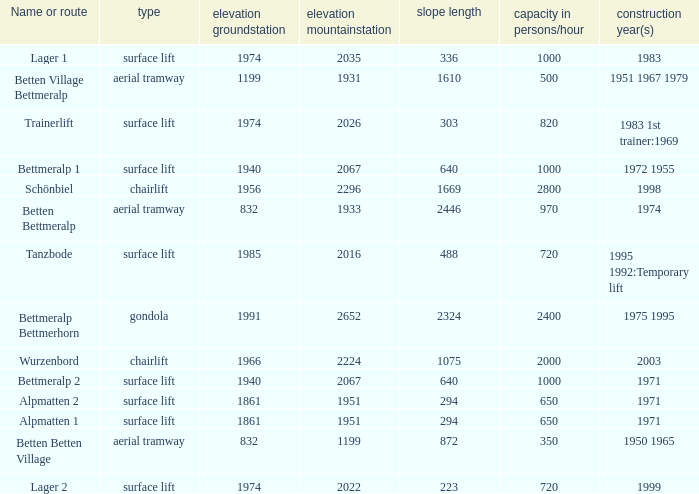Which slope length has a type of surface lift, and an elevation groundstation smaller than 1974, and a construction year(s) of 1971, and a Name or route of alpmatten 1? 294.0. 